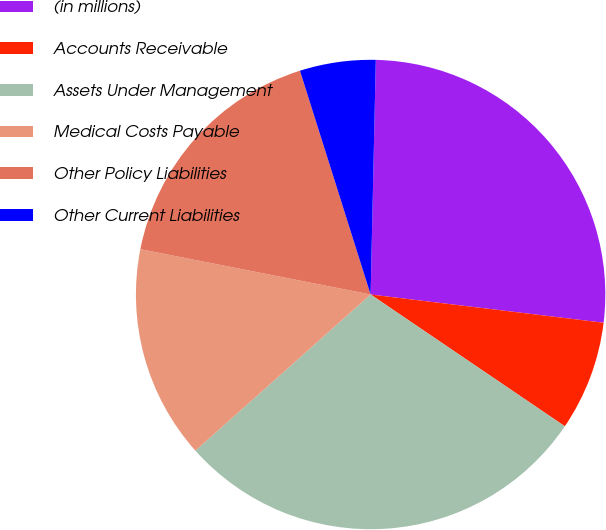Convert chart. <chart><loc_0><loc_0><loc_500><loc_500><pie_chart><fcel>(in millions)<fcel>Accounts Receivable<fcel>Assets Under Management<fcel>Medical Costs Payable<fcel>Other Policy Liabilities<fcel>Other Current Liabilities<nl><fcel>26.57%<fcel>7.57%<fcel>28.93%<fcel>14.68%<fcel>17.04%<fcel>5.22%<nl></chart> 